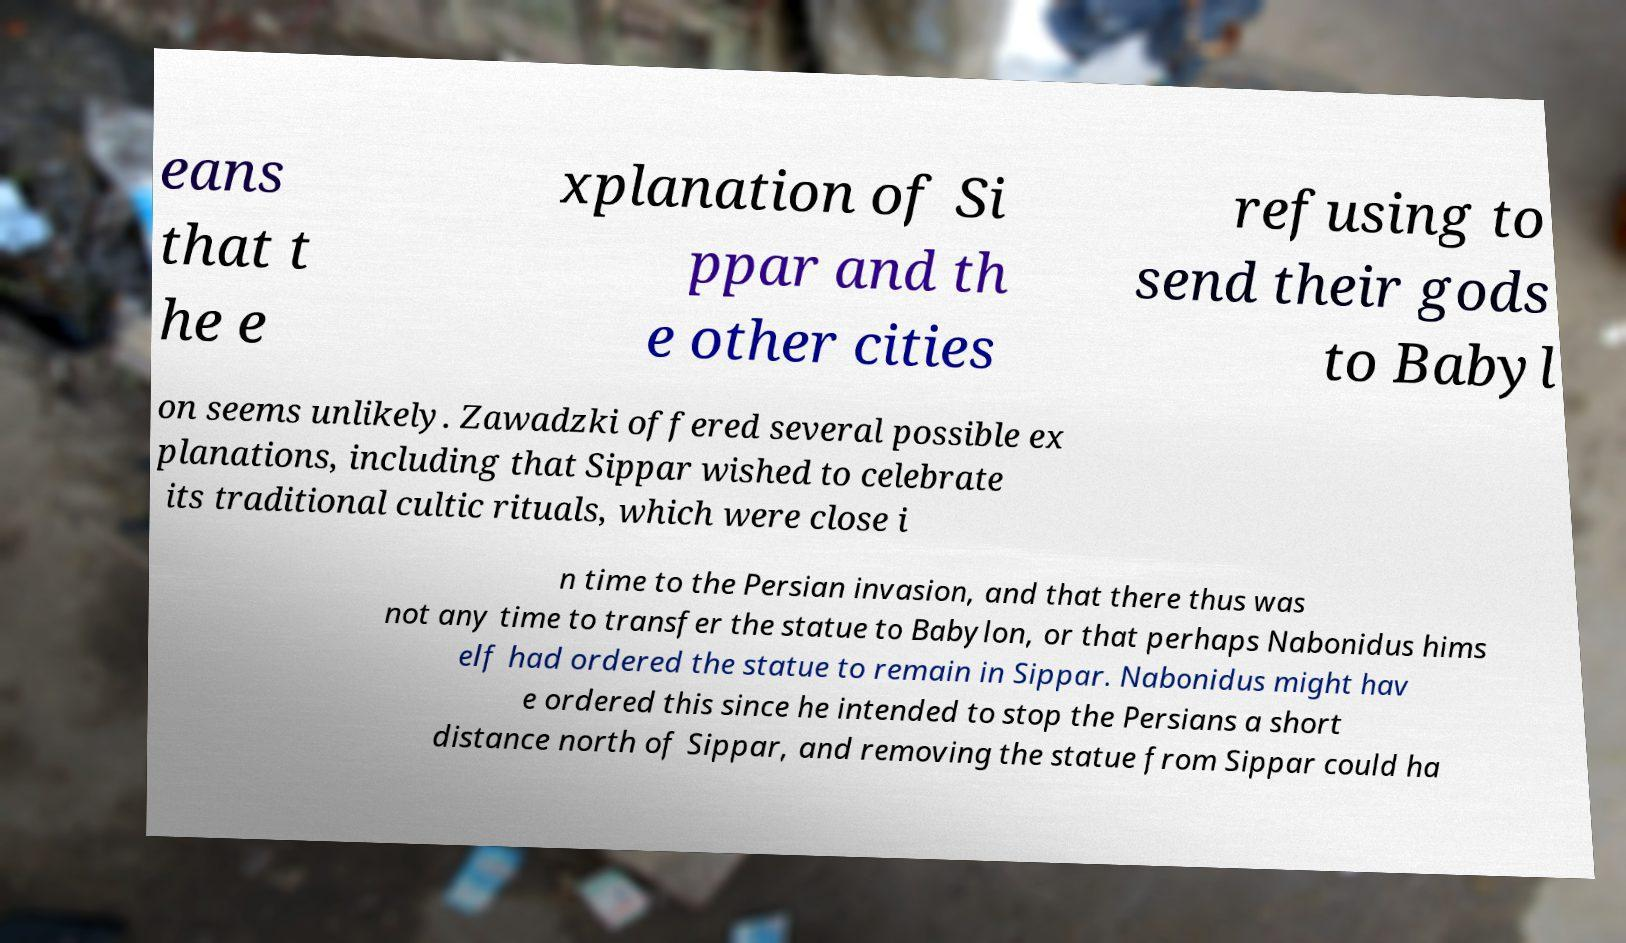Please identify and transcribe the text found in this image. eans that t he e xplanation of Si ppar and th e other cities refusing to send their gods to Babyl on seems unlikely. Zawadzki offered several possible ex planations, including that Sippar wished to celebrate its traditional cultic rituals, which were close i n time to the Persian invasion, and that there thus was not any time to transfer the statue to Babylon, or that perhaps Nabonidus hims elf had ordered the statue to remain in Sippar. Nabonidus might hav e ordered this since he intended to stop the Persians a short distance north of Sippar, and removing the statue from Sippar could ha 